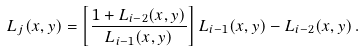<formula> <loc_0><loc_0><loc_500><loc_500>L _ { j } ( x , y ) = \left [ \frac { 1 + L _ { i - 2 } ( x , y ) } { L _ { i - 1 } ( x , y ) } \right ] L _ { i - 1 } ( x , y ) - L _ { i - 2 } ( x , y ) \, .</formula> 